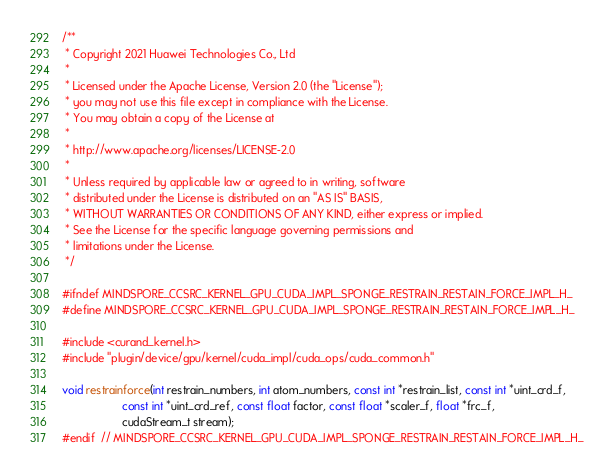<code> <loc_0><loc_0><loc_500><loc_500><_Cuda_>/**
 * Copyright 2021 Huawei Technologies Co., Ltd
 *
 * Licensed under the Apache License, Version 2.0 (the "License");
 * you may not use this file except in compliance with the License.
 * You may obtain a copy of the License at
 *
 * http://www.apache.org/licenses/LICENSE-2.0
 *
 * Unless required by applicable law or agreed to in writing, software
 * distributed under the License is distributed on an "AS IS" BASIS,
 * WITHOUT WARRANTIES OR CONDITIONS OF ANY KIND, either express or implied.
 * See the License for the specific language governing permissions and
 * limitations under the License.
 */

#ifndef MINDSPORE_CCSRC_KERNEL_GPU_CUDA_IMPL_SPONGE_RESTRAIN_RESTAIN_FORCE_IMPL_H_
#define MINDSPORE_CCSRC_KERNEL_GPU_CUDA_IMPL_SPONGE_RESTRAIN_RESTAIN_FORCE_IMPL_H_

#include <curand_kernel.h>
#include "plugin/device/gpu/kernel/cuda_impl/cuda_ops/cuda_common.h"

void restrainforce(int restrain_numbers, int atom_numbers, const int *restrain_list, const int *uint_crd_f,
                   const int *uint_crd_ref, const float factor, const float *scaler_f, float *frc_f,
                   cudaStream_t stream);
#endif  // MINDSPORE_CCSRC_KERNEL_GPU_CUDA_IMPL_SPONGE_RESTRAIN_RESTAIN_FORCE_IMPL_H_
</code> 